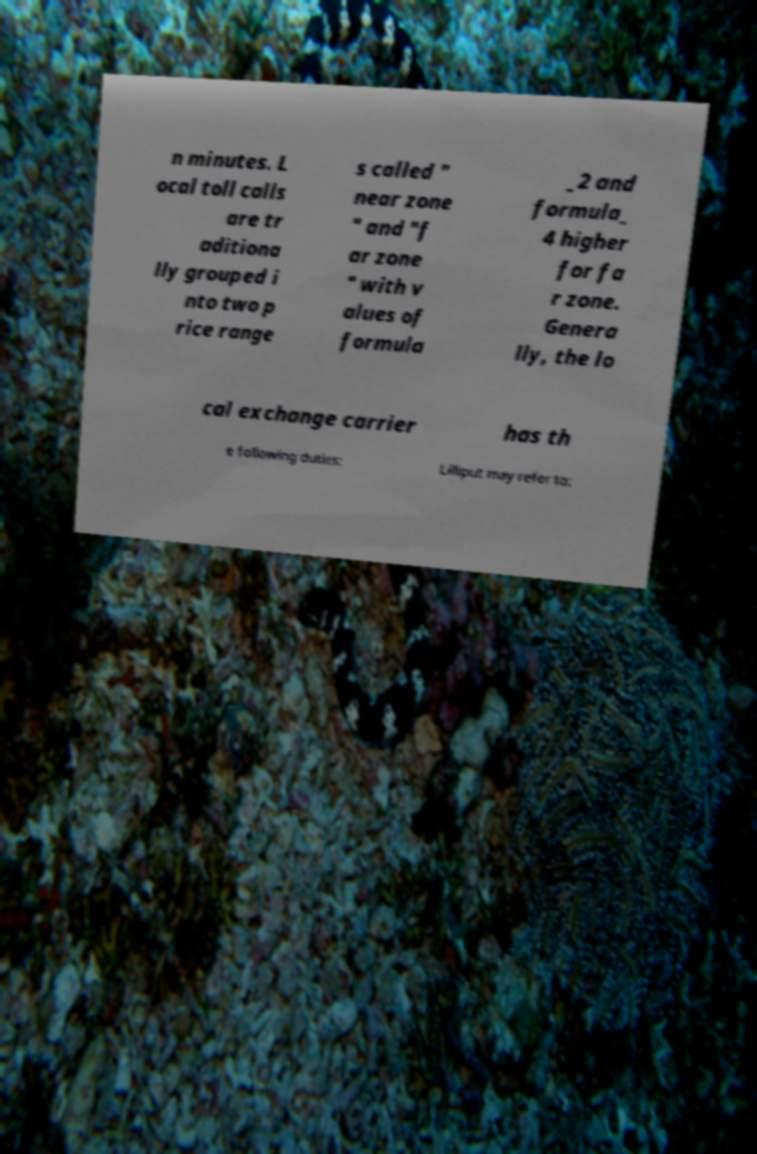Please read and relay the text visible in this image. What does it say? n minutes. L ocal toll calls are tr aditiona lly grouped i nto two p rice range s called " near zone " and "f ar zone " with v alues of formula _2 and formula_ 4 higher for fa r zone. Genera lly, the lo cal exchange carrier has th e following duties: Lilliput may refer to: 